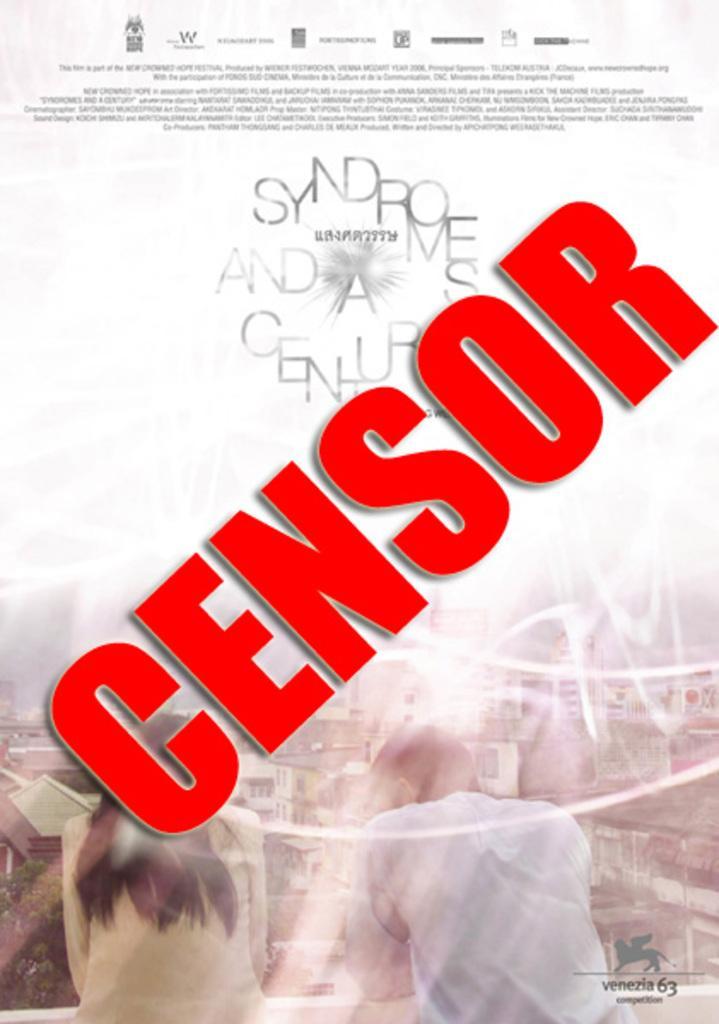Describe this image in one or two sentences. This is an advertisement. At the bottom of the image we can see the buildings, trees, roof, poles and two persons are standing. In the bottom right corner we can see the text and logo. In the background of the image we can see the text and logos. 